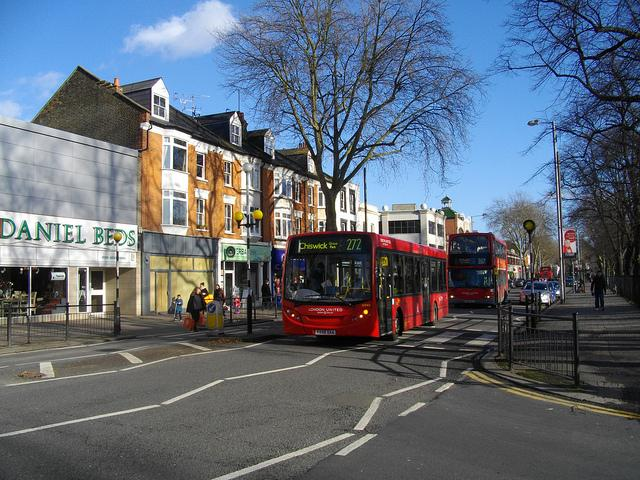What season is it in the image? Please explain your reasoning. fall-winter. The trees are bare.  people are wearing long sleeved shirts. 